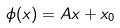Convert formula to latex. <formula><loc_0><loc_0><loc_500><loc_500>\phi ( x ) = A x + x _ { 0 }</formula> 